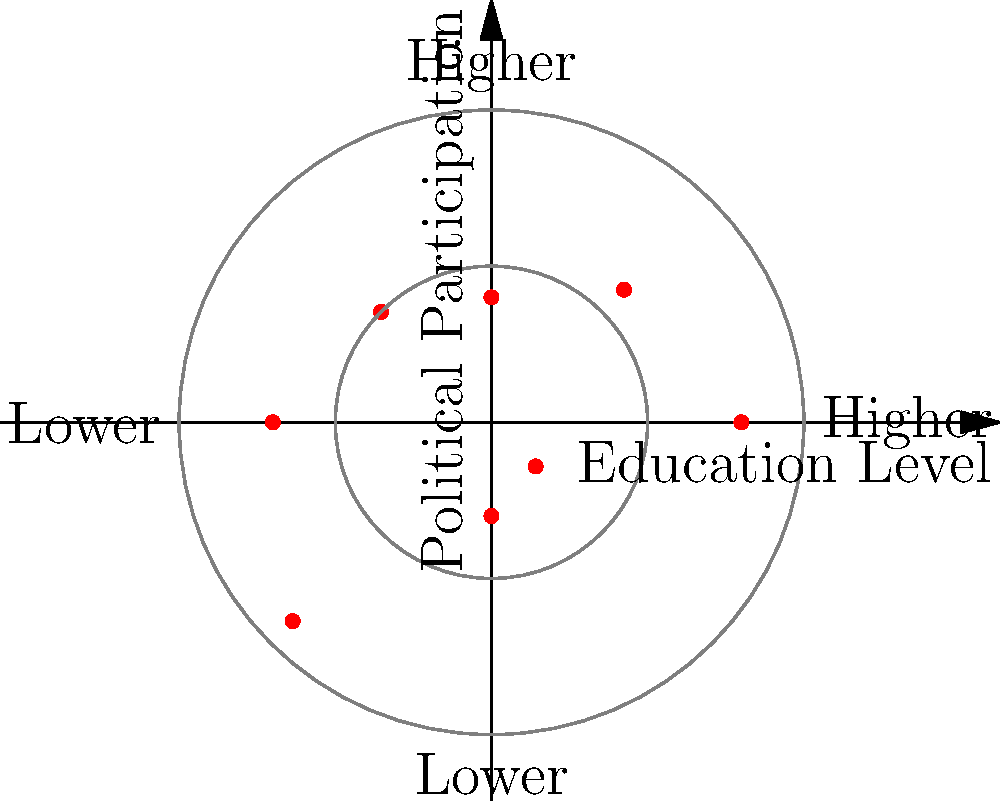The polar coordinate plot shows the relationship between education levels and political participation in various Latin American democracies. Based on the distribution of data points, what can be inferred about the correlation between education levels and political participation in these countries? To analyze the correlation between education levels and political participation, let's follow these steps:

1. Understand the plot:
   - The x-axis represents education levels (right side: higher, left side: lower)
   - The y-axis represents political participation (upper side: higher, lower side: lower)
   - Each data point represents a Latin American country

2. Observe the overall pattern:
   - Most data points are concentrated in the upper-right quadrant
   - There are fewer points in the lower-left quadrant

3. Interpret the pattern:
   - Points in the upper-right quadrant indicate countries with both higher education levels and higher political participation
   - Points in the lower-left quadrant indicate countries with both lower education levels and lower political participation

4. Analyze the correlation:
   - The general trend shows that as education levels increase (moving right), political participation tends to increase (moving up)
   - This suggests a positive correlation between education levels and political participation

5. Consider the strength of the correlation:
   - While there is a clear positive trend, the points are not perfectly aligned
   - This indicates a moderate to strong positive correlation, rather than a perfect one

6. Account for outliers:
   - There are a few points that don't follow the general trend (e.g., in the upper-left and lower-right quadrants)
   - These outliers suggest that while there is a general correlation, other factors may also influence political participation in some countries

Based on this analysis, we can conclude that there is a moderate to strong positive correlation between education levels and political participation in Latin American democracies, with some exceptions.
Answer: Moderate to strong positive correlation 